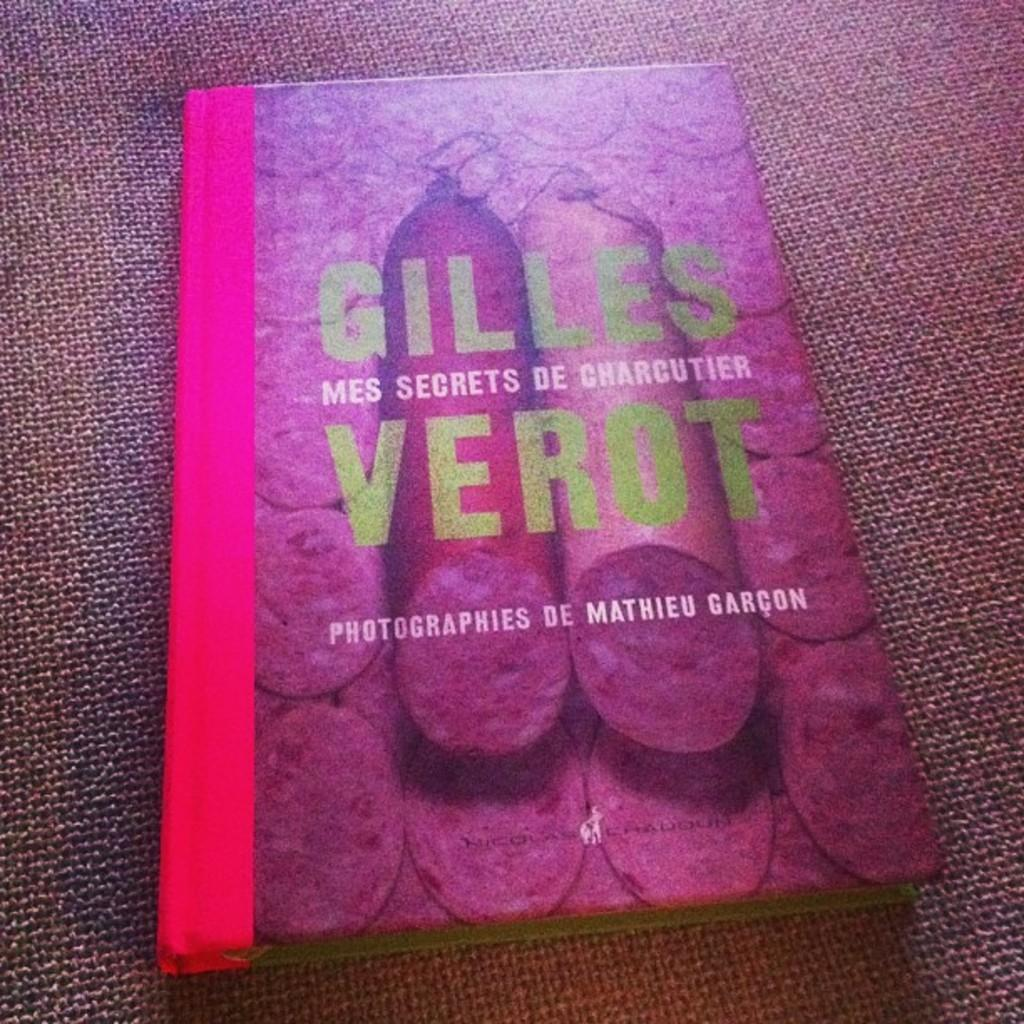<image>
Describe the image concisely. Gilles Verot's book is about charcuterie and has salami on the cover. 